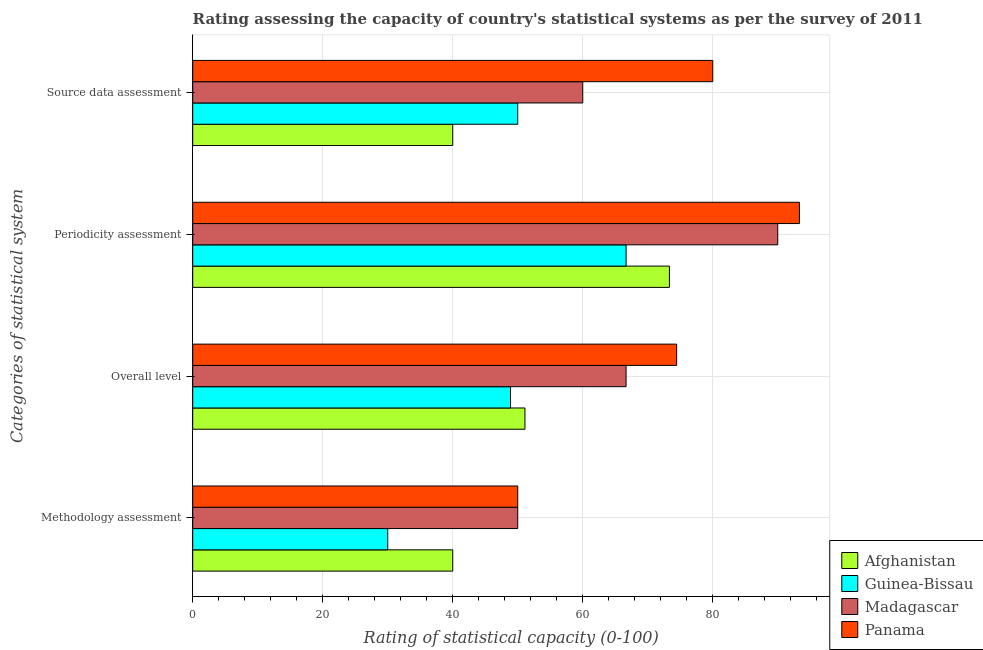How many different coloured bars are there?
Your response must be concise. 4. Are the number of bars on each tick of the Y-axis equal?
Ensure brevity in your answer.  Yes. How many bars are there on the 3rd tick from the top?
Your response must be concise. 4. What is the label of the 2nd group of bars from the top?
Provide a short and direct response. Periodicity assessment. Across all countries, what is the maximum overall level rating?
Provide a succinct answer. 74.44. Across all countries, what is the minimum methodology assessment rating?
Your answer should be very brief. 30. In which country was the periodicity assessment rating maximum?
Your answer should be very brief. Panama. In which country was the overall level rating minimum?
Your answer should be compact. Guinea-Bissau. What is the total overall level rating in the graph?
Offer a very short reply. 241.11. What is the difference between the overall level rating in Afghanistan and the periodicity assessment rating in Madagascar?
Give a very brief answer. -38.89. What is the average overall level rating per country?
Provide a succinct answer. 60.28. What is the difference between the periodicity assessment rating and source data assessment rating in Panama?
Provide a succinct answer. 13.33. What is the ratio of the periodicity assessment rating in Afghanistan to that in Panama?
Make the answer very short. 0.79. Is the difference between the periodicity assessment rating in Afghanistan and Panama greater than the difference between the methodology assessment rating in Afghanistan and Panama?
Keep it short and to the point. No. What is the difference between the highest and the second highest overall level rating?
Make the answer very short. 7.78. Is the sum of the methodology assessment rating in Panama and Madagascar greater than the maximum periodicity assessment rating across all countries?
Ensure brevity in your answer.  Yes. Is it the case that in every country, the sum of the source data assessment rating and overall level rating is greater than the sum of methodology assessment rating and periodicity assessment rating?
Ensure brevity in your answer.  Yes. What does the 4th bar from the top in Source data assessment represents?
Your response must be concise. Afghanistan. What does the 4th bar from the bottom in Periodicity assessment represents?
Your answer should be very brief. Panama. Is it the case that in every country, the sum of the methodology assessment rating and overall level rating is greater than the periodicity assessment rating?
Give a very brief answer. Yes. How many bars are there?
Keep it short and to the point. 16. Are all the bars in the graph horizontal?
Your answer should be compact. Yes. How many countries are there in the graph?
Give a very brief answer. 4. What is the difference between two consecutive major ticks on the X-axis?
Give a very brief answer. 20. Are the values on the major ticks of X-axis written in scientific E-notation?
Offer a terse response. No. Does the graph contain any zero values?
Provide a short and direct response. No. Does the graph contain grids?
Provide a short and direct response. Yes. Where does the legend appear in the graph?
Provide a short and direct response. Bottom right. How many legend labels are there?
Your answer should be compact. 4. What is the title of the graph?
Your answer should be compact. Rating assessing the capacity of country's statistical systems as per the survey of 2011 . Does "Ireland" appear as one of the legend labels in the graph?
Offer a very short reply. No. What is the label or title of the X-axis?
Your response must be concise. Rating of statistical capacity (0-100). What is the label or title of the Y-axis?
Make the answer very short. Categories of statistical system. What is the Rating of statistical capacity (0-100) in Afghanistan in Methodology assessment?
Keep it short and to the point. 40. What is the Rating of statistical capacity (0-100) of Guinea-Bissau in Methodology assessment?
Give a very brief answer. 30. What is the Rating of statistical capacity (0-100) in Madagascar in Methodology assessment?
Provide a succinct answer. 50. What is the Rating of statistical capacity (0-100) of Panama in Methodology assessment?
Make the answer very short. 50. What is the Rating of statistical capacity (0-100) of Afghanistan in Overall level?
Give a very brief answer. 51.11. What is the Rating of statistical capacity (0-100) of Guinea-Bissau in Overall level?
Provide a succinct answer. 48.89. What is the Rating of statistical capacity (0-100) of Madagascar in Overall level?
Your answer should be compact. 66.67. What is the Rating of statistical capacity (0-100) in Panama in Overall level?
Your response must be concise. 74.44. What is the Rating of statistical capacity (0-100) in Afghanistan in Periodicity assessment?
Provide a short and direct response. 73.33. What is the Rating of statistical capacity (0-100) in Guinea-Bissau in Periodicity assessment?
Provide a short and direct response. 66.67. What is the Rating of statistical capacity (0-100) of Panama in Periodicity assessment?
Your answer should be very brief. 93.33. What is the Rating of statistical capacity (0-100) of Guinea-Bissau in Source data assessment?
Offer a very short reply. 50. What is the Rating of statistical capacity (0-100) of Panama in Source data assessment?
Provide a succinct answer. 80. Across all Categories of statistical system, what is the maximum Rating of statistical capacity (0-100) in Afghanistan?
Make the answer very short. 73.33. Across all Categories of statistical system, what is the maximum Rating of statistical capacity (0-100) in Guinea-Bissau?
Keep it short and to the point. 66.67. Across all Categories of statistical system, what is the maximum Rating of statistical capacity (0-100) in Panama?
Give a very brief answer. 93.33. Across all Categories of statistical system, what is the minimum Rating of statistical capacity (0-100) of Afghanistan?
Provide a short and direct response. 40. Across all Categories of statistical system, what is the minimum Rating of statistical capacity (0-100) of Madagascar?
Provide a succinct answer. 50. What is the total Rating of statistical capacity (0-100) in Afghanistan in the graph?
Keep it short and to the point. 204.44. What is the total Rating of statistical capacity (0-100) of Guinea-Bissau in the graph?
Make the answer very short. 195.56. What is the total Rating of statistical capacity (0-100) of Madagascar in the graph?
Provide a succinct answer. 266.67. What is the total Rating of statistical capacity (0-100) in Panama in the graph?
Ensure brevity in your answer.  297.78. What is the difference between the Rating of statistical capacity (0-100) in Afghanistan in Methodology assessment and that in Overall level?
Your answer should be very brief. -11.11. What is the difference between the Rating of statistical capacity (0-100) in Guinea-Bissau in Methodology assessment and that in Overall level?
Give a very brief answer. -18.89. What is the difference between the Rating of statistical capacity (0-100) in Madagascar in Methodology assessment and that in Overall level?
Your answer should be compact. -16.67. What is the difference between the Rating of statistical capacity (0-100) in Panama in Methodology assessment and that in Overall level?
Your answer should be compact. -24.44. What is the difference between the Rating of statistical capacity (0-100) in Afghanistan in Methodology assessment and that in Periodicity assessment?
Offer a terse response. -33.33. What is the difference between the Rating of statistical capacity (0-100) in Guinea-Bissau in Methodology assessment and that in Periodicity assessment?
Ensure brevity in your answer.  -36.67. What is the difference between the Rating of statistical capacity (0-100) in Madagascar in Methodology assessment and that in Periodicity assessment?
Your answer should be very brief. -40. What is the difference between the Rating of statistical capacity (0-100) of Panama in Methodology assessment and that in Periodicity assessment?
Ensure brevity in your answer.  -43.33. What is the difference between the Rating of statistical capacity (0-100) in Madagascar in Methodology assessment and that in Source data assessment?
Offer a terse response. -10. What is the difference between the Rating of statistical capacity (0-100) of Afghanistan in Overall level and that in Periodicity assessment?
Ensure brevity in your answer.  -22.22. What is the difference between the Rating of statistical capacity (0-100) in Guinea-Bissau in Overall level and that in Periodicity assessment?
Offer a very short reply. -17.78. What is the difference between the Rating of statistical capacity (0-100) of Madagascar in Overall level and that in Periodicity assessment?
Offer a terse response. -23.33. What is the difference between the Rating of statistical capacity (0-100) in Panama in Overall level and that in Periodicity assessment?
Offer a very short reply. -18.89. What is the difference between the Rating of statistical capacity (0-100) of Afghanistan in Overall level and that in Source data assessment?
Provide a succinct answer. 11.11. What is the difference between the Rating of statistical capacity (0-100) of Guinea-Bissau in Overall level and that in Source data assessment?
Offer a terse response. -1.11. What is the difference between the Rating of statistical capacity (0-100) of Panama in Overall level and that in Source data assessment?
Your answer should be compact. -5.56. What is the difference between the Rating of statistical capacity (0-100) in Afghanistan in Periodicity assessment and that in Source data assessment?
Give a very brief answer. 33.33. What is the difference between the Rating of statistical capacity (0-100) in Guinea-Bissau in Periodicity assessment and that in Source data assessment?
Your answer should be compact. 16.67. What is the difference between the Rating of statistical capacity (0-100) in Madagascar in Periodicity assessment and that in Source data assessment?
Ensure brevity in your answer.  30. What is the difference between the Rating of statistical capacity (0-100) of Panama in Periodicity assessment and that in Source data assessment?
Your answer should be compact. 13.33. What is the difference between the Rating of statistical capacity (0-100) in Afghanistan in Methodology assessment and the Rating of statistical capacity (0-100) in Guinea-Bissau in Overall level?
Provide a succinct answer. -8.89. What is the difference between the Rating of statistical capacity (0-100) of Afghanistan in Methodology assessment and the Rating of statistical capacity (0-100) of Madagascar in Overall level?
Your response must be concise. -26.67. What is the difference between the Rating of statistical capacity (0-100) in Afghanistan in Methodology assessment and the Rating of statistical capacity (0-100) in Panama in Overall level?
Make the answer very short. -34.44. What is the difference between the Rating of statistical capacity (0-100) of Guinea-Bissau in Methodology assessment and the Rating of statistical capacity (0-100) of Madagascar in Overall level?
Offer a terse response. -36.67. What is the difference between the Rating of statistical capacity (0-100) of Guinea-Bissau in Methodology assessment and the Rating of statistical capacity (0-100) of Panama in Overall level?
Keep it short and to the point. -44.44. What is the difference between the Rating of statistical capacity (0-100) in Madagascar in Methodology assessment and the Rating of statistical capacity (0-100) in Panama in Overall level?
Keep it short and to the point. -24.44. What is the difference between the Rating of statistical capacity (0-100) of Afghanistan in Methodology assessment and the Rating of statistical capacity (0-100) of Guinea-Bissau in Periodicity assessment?
Offer a terse response. -26.67. What is the difference between the Rating of statistical capacity (0-100) of Afghanistan in Methodology assessment and the Rating of statistical capacity (0-100) of Madagascar in Periodicity assessment?
Your answer should be compact. -50. What is the difference between the Rating of statistical capacity (0-100) of Afghanistan in Methodology assessment and the Rating of statistical capacity (0-100) of Panama in Periodicity assessment?
Your answer should be very brief. -53.33. What is the difference between the Rating of statistical capacity (0-100) in Guinea-Bissau in Methodology assessment and the Rating of statistical capacity (0-100) in Madagascar in Periodicity assessment?
Keep it short and to the point. -60. What is the difference between the Rating of statistical capacity (0-100) of Guinea-Bissau in Methodology assessment and the Rating of statistical capacity (0-100) of Panama in Periodicity assessment?
Ensure brevity in your answer.  -63.33. What is the difference between the Rating of statistical capacity (0-100) in Madagascar in Methodology assessment and the Rating of statistical capacity (0-100) in Panama in Periodicity assessment?
Your answer should be very brief. -43.33. What is the difference between the Rating of statistical capacity (0-100) of Afghanistan in Methodology assessment and the Rating of statistical capacity (0-100) of Guinea-Bissau in Source data assessment?
Ensure brevity in your answer.  -10. What is the difference between the Rating of statistical capacity (0-100) in Guinea-Bissau in Methodology assessment and the Rating of statistical capacity (0-100) in Madagascar in Source data assessment?
Make the answer very short. -30. What is the difference between the Rating of statistical capacity (0-100) in Afghanistan in Overall level and the Rating of statistical capacity (0-100) in Guinea-Bissau in Periodicity assessment?
Offer a very short reply. -15.56. What is the difference between the Rating of statistical capacity (0-100) of Afghanistan in Overall level and the Rating of statistical capacity (0-100) of Madagascar in Periodicity assessment?
Keep it short and to the point. -38.89. What is the difference between the Rating of statistical capacity (0-100) of Afghanistan in Overall level and the Rating of statistical capacity (0-100) of Panama in Periodicity assessment?
Your response must be concise. -42.22. What is the difference between the Rating of statistical capacity (0-100) in Guinea-Bissau in Overall level and the Rating of statistical capacity (0-100) in Madagascar in Periodicity assessment?
Offer a terse response. -41.11. What is the difference between the Rating of statistical capacity (0-100) in Guinea-Bissau in Overall level and the Rating of statistical capacity (0-100) in Panama in Periodicity assessment?
Your response must be concise. -44.44. What is the difference between the Rating of statistical capacity (0-100) in Madagascar in Overall level and the Rating of statistical capacity (0-100) in Panama in Periodicity assessment?
Offer a terse response. -26.67. What is the difference between the Rating of statistical capacity (0-100) of Afghanistan in Overall level and the Rating of statistical capacity (0-100) of Guinea-Bissau in Source data assessment?
Give a very brief answer. 1.11. What is the difference between the Rating of statistical capacity (0-100) of Afghanistan in Overall level and the Rating of statistical capacity (0-100) of Madagascar in Source data assessment?
Give a very brief answer. -8.89. What is the difference between the Rating of statistical capacity (0-100) in Afghanistan in Overall level and the Rating of statistical capacity (0-100) in Panama in Source data assessment?
Offer a very short reply. -28.89. What is the difference between the Rating of statistical capacity (0-100) in Guinea-Bissau in Overall level and the Rating of statistical capacity (0-100) in Madagascar in Source data assessment?
Your response must be concise. -11.11. What is the difference between the Rating of statistical capacity (0-100) in Guinea-Bissau in Overall level and the Rating of statistical capacity (0-100) in Panama in Source data assessment?
Your answer should be compact. -31.11. What is the difference between the Rating of statistical capacity (0-100) in Madagascar in Overall level and the Rating of statistical capacity (0-100) in Panama in Source data assessment?
Give a very brief answer. -13.33. What is the difference between the Rating of statistical capacity (0-100) in Afghanistan in Periodicity assessment and the Rating of statistical capacity (0-100) in Guinea-Bissau in Source data assessment?
Offer a terse response. 23.33. What is the difference between the Rating of statistical capacity (0-100) of Afghanistan in Periodicity assessment and the Rating of statistical capacity (0-100) of Madagascar in Source data assessment?
Give a very brief answer. 13.33. What is the difference between the Rating of statistical capacity (0-100) of Afghanistan in Periodicity assessment and the Rating of statistical capacity (0-100) of Panama in Source data assessment?
Provide a short and direct response. -6.67. What is the difference between the Rating of statistical capacity (0-100) in Guinea-Bissau in Periodicity assessment and the Rating of statistical capacity (0-100) in Madagascar in Source data assessment?
Keep it short and to the point. 6.67. What is the difference between the Rating of statistical capacity (0-100) of Guinea-Bissau in Periodicity assessment and the Rating of statistical capacity (0-100) of Panama in Source data assessment?
Your answer should be very brief. -13.33. What is the average Rating of statistical capacity (0-100) of Afghanistan per Categories of statistical system?
Your answer should be compact. 51.11. What is the average Rating of statistical capacity (0-100) of Guinea-Bissau per Categories of statistical system?
Provide a succinct answer. 48.89. What is the average Rating of statistical capacity (0-100) of Madagascar per Categories of statistical system?
Make the answer very short. 66.67. What is the average Rating of statistical capacity (0-100) of Panama per Categories of statistical system?
Provide a short and direct response. 74.44. What is the difference between the Rating of statistical capacity (0-100) in Afghanistan and Rating of statistical capacity (0-100) in Guinea-Bissau in Methodology assessment?
Ensure brevity in your answer.  10. What is the difference between the Rating of statistical capacity (0-100) in Afghanistan and Rating of statistical capacity (0-100) in Madagascar in Methodology assessment?
Your answer should be very brief. -10. What is the difference between the Rating of statistical capacity (0-100) in Afghanistan and Rating of statistical capacity (0-100) in Guinea-Bissau in Overall level?
Your answer should be very brief. 2.22. What is the difference between the Rating of statistical capacity (0-100) in Afghanistan and Rating of statistical capacity (0-100) in Madagascar in Overall level?
Ensure brevity in your answer.  -15.56. What is the difference between the Rating of statistical capacity (0-100) of Afghanistan and Rating of statistical capacity (0-100) of Panama in Overall level?
Ensure brevity in your answer.  -23.33. What is the difference between the Rating of statistical capacity (0-100) in Guinea-Bissau and Rating of statistical capacity (0-100) in Madagascar in Overall level?
Ensure brevity in your answer.  -17.78. What is the difference between the Rating of statistical capacity (0-100) of Guinea-Bissau and Rating of statistical capacity (0-100) of Panama in Overall level?
Make the answer very short. -25.56. What is the difference between the Rating of statistical capacity (0-100) of Madagascar and Rating of statistical capacity (0-100) of Panama in Overall level?
Make the answer very short. -7.78. What is the difference between the Rating of statistical capacity (0-100) in Afghanistan and Rating of statistical capacity (0-100) in Madagascar in Periodicity assessment?
Give a very brief answer. -16.67. What is the difference between the Rating of statistical capacity (0-100) of Guinea-Bissau and Rating of statistical capacity (0-100) of Madagascar in Periodicity assessment?
Your answer should be very brief. -23.33. What is the difference between the Rating of statistical capacity (0-100) in Guinea-Bissau and Rating of statistical capacity (0-100) in Panama in Periodicity assessment?
Give a very brief answer. -26.67. What is the difference between the Rating of statistical capacity (0-100) of Madagascar and Rating of statistical capacity (0-100) of Panama in Periodicity assessment?
Provide a short and direct response. -3.33. What is the difference between the Rating of statistical capacity (0-100) of Afghanistan and Rating of statistical capacity (0-100) of Madagascar in Source data assessment?
Your answer should be very brief. -20. What is the difference between the Rating of statistical capacity (0-100) of Afghanistan and Rating of statistical capacity (0-100) of Panama in Source data assessment?
Your response must be concise. -40. What is the ratio of the Rating of statistical capacity (0-100) in Afghanistan in Methodology assessment to that in Overall level?
Your answer should be compact. 0.78. What is the ratio of the Rating of statistical capacity (0-100) of Guinea-Bissau in Methodology assessment to that in Overall level?
Offer a very short reply. 0.61. What is the ratio of the Rating of statistical capacity (0-100) of Madagascar in Methodology assessment to that in Overall level?
Give a very brief answer. 0.75. What is the ratio of the Rating of statistical capacity (0-100) in Panama in Methodology assessment to that in Overall level?
Make the answer very short. 0.67. What is the ratio of the Rating of statistical capacity (0-100) of Afghanistan in Methodology assessment to that in Periodicity assessment?
Your answer should be compact. 0.55. What is the ratio of the Rating of statistical capacity (0-100) in Guinea-Bissau in Methodology assessment to that in Periodicity assessment?
Make the answer very short. 0.45. What is the ratio of the Rating of statistical capacity (0-100) in Madagascar in Methodology assessment to that in Periodicity assessment?
Provide a succinct answer. 0.56. What is the ratio of the Rating of statistical capacity (0-100) of Panama in Methodology assessment to that in Periodicity assessment?
Your response must be concise. 0.54. What is the ratio of the Rating of statistical capacity (0-100) in Afghanistan in Overall level to that in Periodicity assessment?
Offer a terse response. 0.7. What is the ratio of the Rating of statistical capacity (0-100) in Guinea-Bissau in Overall level to that in Periodicity assessment?
Your response must be concise. 0.73. What is the ratio of the Rating of statistical capacity (0-100) of Madagascar in Overall level to that in Periodicity assessment?
Make the answer very short. 0.74. What is the ratio of the Rating of statistical capacity (0-100) of Panama in Overall level to that in Periodicity assessment?
Provide a succinct answer. 0.8. What is the ratio of the Rating of statistical capacity (0-100) in Afghanistan in Overall level to that in Source data assessment?
Offer a terse response. 1.28. What is the ratio of the Rating of statistical capacity (0-100) in Guinea-Bissau in Overall level to that in Source data assessment?
Offer a very short reply. 0.98. What is the ratio of the Rating of statistical capacity (0-100) of Madagascar in Overall level to that in Source data assessment?
Make the answer very short. 1.11. What is the ratio of the Rating of statistical capacity (0-100) in Panama in Overall level to that in Source data assessment?
Your answer should be very brief. 0.93. What is the ratio of the Rating of statistical capacity (0-100) in Afghanistan in Periodicity assessment to that in Source data assessment?
Give a very brief answer. 1.83. What is the ratio of the Rating of statistical capacity (0-100) of Madagascar in Periodicity assessment to that in Source data assessment?
Ensure brevity in your answer.  1.5. What is the difference between the highest and the second highest Rating of statistical capacity (0-100) in Afghanistan?
Provide a succinct answer. 22.22. What is the difference between the highest and the second highest Rating of statistical capacity (0-100) in Guinea-Bissau?
Provide a short and direct response. 16.67. What is the difference between the highest and the second highest Rating of statistical capacity (0-100) in Madagascar?
Provide a succinct answer. 23.33. What is the difference between the highest and the second highest Rating of statistical capacity (0-100) of Panama?
Provide a short and direct response. 13.33. What is the difference between the highest and the lowest Rating of statistical capacity (0-100) of Afghanistan?
Offer a very short reply. 33.33. What is the difference between the highest and the lowest Rating of statistical capacity (0-100) in Guinea-Bissau?
Give a very brief answer. 36.67. What is the difference between the highest and the lowest Rating of statistical capacity (0-100) in Panama?
Ensure brevity in your answer.  43.33. 